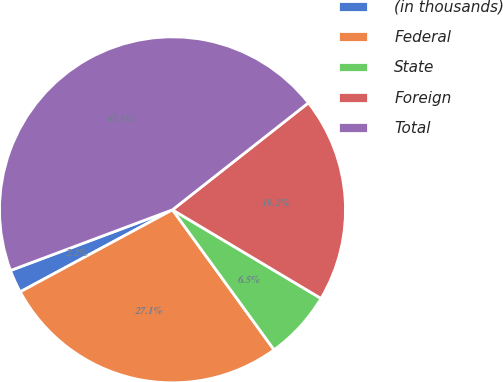Convert chart. <chart><loc_0><loc_0><loc_500><loc_500><pie_chart><fcel>(in thousands)<fcel>Federal<fcel>State<fcel>Foreign<fcel>Total<nl><fcel>2.16%<fcel>27.12%<fcel>6.45%<fcel>19.17%<fcel>45.09%<nl></chart> 